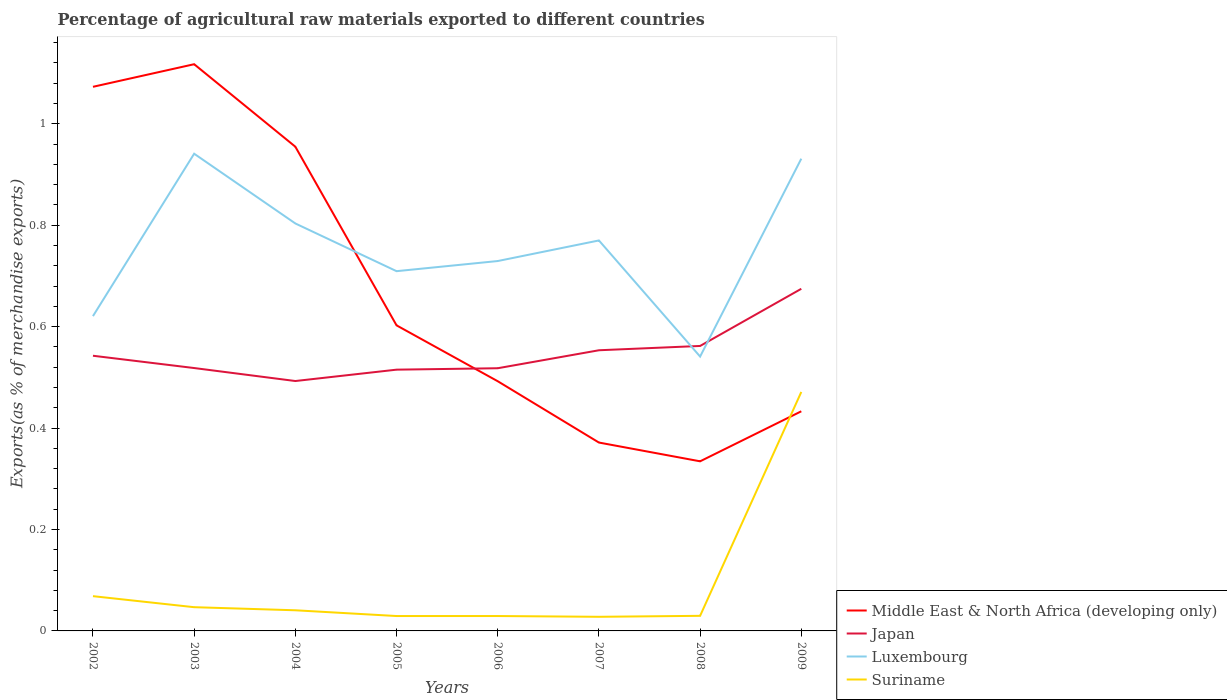How many different coloured lines are there?
Your response must be concise. 4. Is the number of lines equal to the number of legend labels?
Offer a terse response. Yes. Across all years, what is the maximum percentage of exports to different countries in Luxembourg?
Give a very brief answer. 0.54. In which year was the percentage of exports to different countries in Japan maximum?
Ensure brevity in your answer.  2004. What is the total percentage of exports to different countries in Middle East & North Africa (developing only) in the graph?
Your response must be concise. 0.17. What is the difference between the highest and the second highest percentage of exports to different countries in Luxembourg?
Keep it short and to the point. 0.4. Is the percentage of exports to different countries in Middle East & North Africa (developing only) strictly greater than the percentage of exports to different countries in Japan over the years?
Make the answer very short. No. How many lines are there?
Make the answer very short. 4. Does the graph contain any zero values?
Keep it short and to the point. No. What is the title of the graph?
Your answer should be compact. Percentage of agricultural raw materials exported to different countries. What is the label or title of the Y-axis?
Your answer should be compact. Exports(as % of merchandise exports). What is the Exports(as % of merchandise exports) of Middle East & North Africa (developing only) in 2002?
Offer a very short reply. 1.07. What is the Exports(as % of merchandise exports) of Japan in 2002?
Your answer should be compact. 0.54. What is the Exports(as % of merchandise exports) in Luxembourg in 2002?
Give a very brief answer. 0.62. What is the Exports(as % of merchandise exports) in Suriname in 2002?
Your answer should be compact. 0.07. What is the Exports(as % of merchandise exports) of Middle East & North Africa (developing only) in 2003?
Keep it short and to the point. 1.12. What is the Exports(as % of merchandise exports) of Japan in 2003?
Offer a very short reply. 0.52. What is the Exports(as % of merchandise exports) in Luxembourg in 2003?
Your response must be concise. 0.94. What is the Exports(as % of merchandise exports) of Suriname in 2003?
Your response must be concise. 0.05. What is the Exports(as % of merchandise exports) in Middle East & North Africa (developing only) in 2004?
Make the answer very short. 0.95. What is the Exports(as % of merchandise exports) of Japan in 2004?
Provide a short and direct response. 0.49. What is the Exports(as % of merchandise exports) of Luxembourg in 2004?
Your response must be concise. 0.8. What is the Exports(as % of merchandise exports) of Suriname in 2004?
Make the answer very short. 0.04. What is the Exports(as % of merchandise exports) of Middle East & North Africa (developing only) in 2005?
Offer a terse response. 0.6. What is the Exports(as % of merchandise exports) of Japan in 2005?
Ensure brevity in your answer.  0.52. What is the Exports(as % of merchandise exports) in Luxembourg in 2005?
Make the answer very short. 0.71. What is the Exports(as % of merchandise exports) of Suriname in 2005?
Offer a very short reply. 0.03. What is the Exports(as % of merchandise exports) of Middle East & North Africa (developing only) in 2006?
Ensure brevity in your answer.  0.49. What is the Exports(as % of merchandise exports) of Japan in 2006?
Your answer should be very brief. 0.52. What is the Exports(as % of merchandise exports) in Luxembourg in 2006?
Give a very brief answer. 0.73. What is the Exports(as % of merchandise exports) of Suriname in 2006?
Make the answer very short. 0.03. What is the Exports(as % of merchandise exports) of Middle East & North Africa (developing only) in 2007?
Offer a very short reply. 0.37. What is the Exports(as % of merchandise exports) of Japan in 2007?
Offer a very short reply. 0.55. What is the Exports(as % of merchandise exports) of Luxembourg in 2007?
Provide a succinct answer. 0.77. What is the Exports(as % of merchandise exports) in Suriname in 2007?
Keep it short and to the point. 0.03. What is the Exports(as % of merchandise exports) in Middle East & North Africa (developing only) in 2008?
Provide a succinct answer. 0.33. What is the Exports(as % of merchandise exports) of Japan in 2008?
Offer a very short reply. 0.56. What is the Exports(as % of merchandise exports) of Luxembourg in 2008?
Ensure brevity in your answer.  0.54. What is the Exports(as % of merchandise exports) of Suriname in 2008?
Your response must be concise. 0.03. What is the Exports(as % of merchandise exports) in Middle East & North Africa (developing only) in 2009?
Make the answer very short. 0.43. What is the Exports(as % of merchandise exports) in Japan in 2009?
Your answer should be compact. 0.67. What is the Exports(as % of merchandise exports) of Luxembourg in 2009?
Provide a short and direct response. 0.93. What is the Exports(as % of merchandise exports) in Suriname in 2009?
Offer a terse response. 0.47. Across all years, what is the maximum Exports(as % of merchandise exports) in Middle East & North Africa (developing only)?
Give a very brief answer. 1.12. Across all years, what is the maximum Exports(as % of merchandise exports) of Japan?
Your answer should be compact. 0.67. Across all years, what is the maximum Exports(as % of merchandise exports) in Luxembourg?
Your response must be concise. 0.94. Across all years, what is the maximum Exports(as % of merchandise exports) of Suriname?
Provide a succinct answer. 0.47. Across all years, what is the minimum Exports(as % of merchandise exports) of Middle East & North Africa (developing only)?
Your answer should be very brief. 0.33. Across all years, what is the minimum Exports(as % of merchandise exports) of Japan?
Make the answer very short. 0.49. Across all years, what is the minimum Exports(as % of merchandise exports) of Luxembourg?
Your answer should be compact. 0.54. Across all years, what is the minimum Exports(as % of merchandise exports) of Suriname?
Provide a short and direct response. 0.03. What is the total Exports(as % of merchandise exports) of Middle East & North Africa (developing only) in the graph?
Ensure brevity in your answer.  5.38. What is the total Exports(as % of merchandise exports) of Japan in the graph?
Your answer should be very brief. 4.38. What is the total Exports(as % of merchandise exports) in Luxembourg in the graph?
Your answer should be very brief. 6.05. What is the total Exports(as % of merchandise exports) of Suriname in the graph?
Your answer should be compact. 0.74. What is the difference between the Exports(as % of merchandise exports) in Middle East & North Africa (developing only) in 2002 and that in 2003?
Provide a short and direct response. -0.04. What is the difference between the Exports(as % of merchandise exports) of Japan in 2002 and that in 2003?
Give a very brief answer. 0.02. What is the difference between the Exports(as % of merchandise exports) in Luxembourg in 2002 and that in 2003?
Your answer should be compact. -0.32. What is the difference between the Exports(as % of merchandise exports) in Suriname in 2002 and that in 2003?
Your response must be concise. 0.02. What is the difference between the Exports(as % of merchandise exports) of Middle East & North Africa (developing only) in 2002 and that in 2004?
Offer a terse response. 0.12. What is the difference between the Exports(as % of merchandise exports) of Japan in 2002 and that in 2004?
Provide a short and direct response. 0.05. What is the difference between the Exports(as % of merchandise exports) of Luxembourg in 2002 and that in 2004?
Offer a terse response. -0.18. What is the difference between the Exports(as % of merchandise exports) of Suriname in 2002 and that in 2004?
Provide a succinct answer. 0.03. What is the difference between the Exports(as % of merchandise exports) in Middle East & North Africa (developing only) in 2002 and that in 2005?
Offer a terse response. 0.47. What is the difference between the Exports(as % of merchandise exports) of Japan in 2002 and that in 2005?
Keep it short and to the point. 0.03. What is the difference between the Exports(as % of merchandise exports) in Luxembourg in 2002 and that in 2005?
Offer a terse response. -0.09. What is the difference between the Exports(as % of merchandise exports) of Suriname in 2002 and that in 2005?
Keep it short and to the point. 0.04. What is the difference between the Exports(as % of merchandise exports) in Middle East & North Africa (developing only) in 2002 and that in 2006?
Provide a short and direct response. 0.58. What is the difference between the Exports(as % of merchandise exports) in Japan in 2002 and that in 2006?
Your answer should be very brief. 0.02. What is the difference between the Exports(as % of merchandise exports) of Luxembourg in 2002 and that in 2006?
Keep it short and to the point. -0.11. What is the difference between the Exports(as % of merchandise exports) in Suriname in 2002 and that in 2006?
Your response must be concise. 0.04. What is the difference between the Exports(as % of merchandise exports) of Middle East & North Africa (developing only) in 2002 and that in 2007?
Provide a short and direct response. 0.7. What is the difference between the Exports(as % of merchandise exports) in Japan in 2002 and that in 2007?
Your answer should be very brief. -0.01. What is the difference between the Exports(as % of merchandise exports) of Luxembourg in 2002 and that in 2007?
Your answer should be very brief. -0.15. What is the difference between the Exports(as % of merchandise exports) of Suriname in 2002 and that in 2007?
Make the answer very short. 0.04. What is the difference between the Exports(as % of merchandise exports) of Middle East & North Africa (developing only) in 2002 and that in 2008?
Give a very brief answer. 0.74. What is the difference between the Exports(as % of merchandise exports) of Japan in 2002 and that in 2008?
Offer a terse response. -0.02. What is the difference between the Exports(as % of merchandise exports) in Luxembourg in 2002 and that in 2008?
Make the answer very short. 0.08. What is the difference between the Exports(as % of merchandise exports) in Suriname in 2002 and that in 2008?
Your answer should be very brief. 0.04. What is the difference between the Exports(as % of merchandise exports) of Middle East & North Africa (developing only) in 2002 and that in 2009?
Give a very brief answer. 0.64. What is the difference between the Exports(as % of merchandise exports) in Japan in 2002 and that in 2009?
Keep it short and to the point. -0.13. What is the difference between the Exports(as % of merchandise exports) of Luxembourg in 2002 and that in 2009?
Your answer should be very brief. -0.31. What is the difference between the Exports(as % of merchandise exports) of Suriname in 2002 and that in 2009?
Offer a very short reply. -0.4. What is the difference between the Exports(as % of merchandise exports) in Middle East & North Africa (developing only) in 2003 and that in 2004?
Your response must be concise. 0.16. What is the difference between the Exports(as % of merchandise exports) in Japan in 2003 and that in 2004?
Your response must be concise. 0.03. What is the difference between the Exports(as % of merchandise exports) in Luxembourg in 2003 and that in 2004?
Your answer should be very brief. 0.14. What is the difference between the Exports(as % of merchandise exports) in Suriname in 2003 and that in 2004?
Offer a very short reply. 0.01. What is the difference between the Exports(as % of merchandise exports) in Middle East & North Africa (developing only) in 2003 and that in 2005?
Your answer should be very brief. 0.52. What is the difference between the Exports(as % of merchandise exports) in Japan in 2003 and that in 2005?
Your answer should be compact. 0. What is the difference between the Exports(as % of merchandise exports) in Luxembourg in 2003 and that in 2005?
Your response must be concise. 0.23. What is the difference between the Exports(as % of merchandise exports) in Suriname in 2003 and that in 2005?
Offer a terse response. 0.02. What is the difference between the Exports(as % of merchandise exports) in Middle East & North Africa (developing only) in 2003 and that in 2006?
Keep it short and to the point. 0.63. What is the difference between the Exports(as % of merchandise exports) of Japan in 2003 and that in 2006?
Give a very brief answer. 0. What is the difference between the Exports(as % of merchandise exports) in Luxembourg in 2003 and that in 2006?
Your response must be concise. 0.21. What is the difference between the Exports(as % of merchandise exports) of Suriname in 2003 and that in 2006?
Provide a short and direct response. 0.02. What is the difference between the Exports(as % of merchandise exports) of Middle East & North Africa (developing only) in 2003 and that in 2007?
Your answer should be very brief. 0.75. What is the difference between the Exports(as % of merchandise exports) in Japan in 2003 and that in 2007?
Keep it short and to the point. -0.04. What is the difference between the Exports(as % of merchandise exports) in Luxembourg in 2003 and that in 2007?
Offer a terse response. 0.17. What is the difference between the Exports(as % of merchandise exports) in Suriname in 2003 and that in 2007?
Offer a terse response. 0.02. What is the difference between the Exports(as % of merchandise exports) of Middle East & North Africa (developing only) in 2003 and that in 2008?
Make the answer very short. 0.78. What is the difference between the Exports(as % of merchandise exports) in Japan in 2003 and that in 2008?
Your response must be concise. -0.04. What is the difference between the Exports(as % of merchandise exports) of Luxembourg in 2003 and that in 2008?
Ensure brevity in your answer.  0.4. What is the difference between the Exports(as % of merchandise exports) of Suriname in 2003 and that in 2008?
Offer a terse response. 0.02. What is the difference between the Exports(as % of merchandise exports) of Middle East & North Africa (developing only) in 2003 and that in 2009?
Make the answer very short. 0.68. What is the difference between the Exports(as % of merchandise exports) in Japan in 2003 and that in 2009?
Ensure brevity in your answer.  -0.16. What is the difference between the Exports(as % of merchandise exports) in Luxembourg in 2003 and that in 2009?
Ensure brevity in your answer.  0.01. What is the difference between the Exports(as % of merchandise exports) of Suriname in 2003 and that in 2009?
Make the answer very short. -0.42. What is the difference between the Exports(as % of merchandise exports) in Middle East & North Africa (developing only) in 2004 and that in 2005?
Offer a terse response. 0.35. What is the difference between the Exports(as % of merchandise exports) of Japan in 2004 and that in 2005?
Your response must be concise. -0.02. What is the difference between the Exports(as % of merchandise exports) in Luxembourg in 2004 and that in 2005?
Your answer should be very brief. 0.09. What is the difference between the Exports(as % of merchandise exports) in Suriname in 2004 and that in 2005?
Keep it short and to the point. 0.01. What is the difference between the Exports(as % of merchandise exports) in Middle East & North Africa (developing only) in 2004 and that in 2006?
Offer a terse response. 0.46. What is the difference between the Exports(as % of merchandise exports) in Japan in 2004 and that in 2006?
Offer a terse response. -0.03. What is the difference between the Exports(as % of merchandise exports) in Luxembourg in 2004 and that in 2006?
Offer a terse response. 0.07. What is the difference between the Exports(as % of merchandise exports) in Suriname in 2004 and that in 2006?
Provide a short and direct response. 0.01. What is the difference between the Exports(as % of merchandise exports) of Middle East & North Africa (developing only) in 2004 and that in 2007?
Your answer should be compact. 0.58. What is the difference between the Exports(as % of merchandise exports) in Japan in 2004 and that in 2007?
Provide a succinct answer. -0.06. What is the difference between the Exports(as % of merchandise exports) in Luxembourg in 2004 and that in 2007?
Offer a very short reply. 0.03. What is the difference between the Exports(as % of merchandise exports) of Suriname in 2004 and that in 2007?
Offer a terse response. 0.01. What is the difference between the Exports(as % of merchandise exports) of Middle East & North Africa (developing only) in 2004 and that in 2008?
Make the answer very short. 0.62. What is the difference between the Exports(as % of merchandise exports) of Japan in 2004 and that in 2008?
Provide a short and direct response. -0.07. What is the difference between the Exports(as % of merchandise exports) in Luxembourg in 2004 and that in 2008?
Your response must be concise. 0.26. What is the difference between the Exports(as % of merchandise exports) in Suriname in 2004 and that in 2008?
Provide a succinct answer. 0.01. What is the difference between the Exports(as % of merchandise exports) in Middle East & North Africa (developing only) in 2004 and that in 2009?
Offer a very short reply. 0.52. What is the difference between the Exports(as % of merchandise exports) of Japan in 2004 and that in 2009?
Offer a terse response. -0.18. What is the difference between the Exports(as % of merchandise exports) of Luxembourg in 2004 and that in 2009?
Provide a short and direct response. -0.13. What is the difference between the Exports(as % of merchandise exports) of Suriname in 2004 and that in 2009?
Give a very brief answer. -0.43. What is the difference between the Exports(as % of merchandise exports) of Middle East & North Africa (developing only) in 2005 and that in 2006?
Ensure brevity in your answer.  0.11. What is the difference between the Exports(as % of merchandise exports) of Japan in 2005 and that in 2006?
Give a very brief answer. -0. What is the difference between the Exports(as % of merchandise exports) of Luxembourg in 2005 and that in 2006?
Make the answer very short. -0.02. What is the difference between the Exports(as % of merchandise exports) in Suriname in 2005 and that in 2006?
Keep it short and to the point. 0. What is the difference between the Exports(as % of merchandise exports) of Middle East & North Africa (developing only) in 2005 and that in 2007?
Your response must be concise. 0.23. What is the difference between the Exports(as % of merchandise exports) in Japan in 2005 and that in 2007?
Provide a succinct answer. -0.04. What is the difference between the Exports(as % of merchandise exports) of Luxembourg in 2005 and that in 2007?
Give a very brief answer. -0.06. What is the difference between the Exports(as % of merchandise exports) of Suriname in 2005 and that in 2007?
Provide a succinct answer. 0. What is the difference between the Exports(as % of merchandise exports) of Middle East & North Africa (developing only) in 2005 and that in 2008?
Make the answer very short. 0.27. What is the difference between the Exports(as % of merchandise exports) of Japan in 2005 and that in 2008?
Make the answer very short. -0.05. What is the difference between the Exports(as % of merchandise exports) of Luxembourg in 2005 and that in 2008?
Your response must be concise. 0.17. What is the difference between the Exports(as % of merchandise exports) of Suriname in 2005 and that in 2008?
Your response must be concise. -0. What is the difference between the Exports(as % of merchandise exports) in Middle East & North Africa (developing only) in 2005 and that in 2009?
Ensure brevity in your answer.  0.17. What is the difference between the Exports(as % of merchandise exports) in Japan in 2005 and that in 2009?
Make the answer very short. -0.16. What is the difference between the Exports(as % of merchandise exports) of Luxembourg in 2005 and that in 2009?
Offer a terse response. -0.22. What is the difference between the Exports(as % of merchandise exports) of Suriname in 2005 and that in 2009?
Keep it short and to the point. -0.44. What is the difference between the Exports(as % of merchandise exports) of Middle East & North Africa (developing only) in 2006 and that in 2007?
Make the answer very short. 0.12. What is the difference between the Exports(as % of merchandise exports) in Japan in 2006 and that in 2007?
Your response must be concise. -0.04. What is the difference between the Exports(as % of merchandise exports) of Luxembourg in 2006 and that in 2007?
Make the answer very short. -0.04. What is the difference between the Exports(as % of merchandise exports) of Suriname in 2006 and that in 2007?
Provide a succinct answer. 0. What is the difference between the Exports(as % of merchandise exports) of Middle East & North Africa (developing only) in 2006 and that in 2008?
Your answer should be very brief. 0.16. What is the difference between the Exports(as % of merchandise exports) in Japan in 2006 and that in 2008?
Your answer should be very brief. -0.04. What is the difference between the Exports(as % of merchandise exports) in Luxembourg in 2006 and that in 2008?
Provide a succinct answer. 0.19. What is the difference between the Exports(as % of merchandise exports) of Suriname in 2006 and that in 2008?
Provide a succinct answer. -0. What is the difference between the Exports(as % of merchandise exports) in Middle East & North Africa (developing only) in 2006 and that in 2009?
Give a very brief answer. 0.06. What is the difference between the Exports(as % of merchandise exports) of Japan in 2006 and that in 2009?
Your answer should be very brief. -0.16. What is the difference between the Exports(as % of merchandise exports) of Luxembourg in 2006 and that in 2009?
Offer a very short reply. -0.2. What is the difference between the Exports(as % of merchandise exports) of Suriname in 2006 and that in 2009?
Offer a terse response. -0.44. What is the difference between the Exports(as % of merchandise exports) in Middle East & North Africa (developing only) in 2007 and that in 2008?
Keep it short and to the point. 0.04. What is the difference between the Exports(as % of merchandise exports) in Japan in 2007 and that in 2008?
Make the answer very short. -0.01. What is the difference between the Exports(as % of merchandise exports) of Luxembourg in 2007 and that in 2008?
Offer a very short reply. 0.23. What is the difference between the Exports(as % of merchandise exports) of Suriname in 2007 and that in 2008?
Offer a terse response. -0. What is the difference between the Exports(as % of merchandise exports) of Middle East & North Africa (developing only) in 2007 and that in 2009?
Ensure brevity in your answer.  -0.06. What is the difference between the Exports(as % of merchandise exports) in Japan in 2007 and that in 2009?
Offer a terse response. -0.12. What is the difference between the Exports(as % of merchandise exports) in Luxembourg in 2007 and that in 2009?
Your answer should be compact. -0.16. What is the difference between the Exports(as % of merchandise exports) in Suriname in 2007 and that in 2009?
Provide a succinct answer. -0.44. What is the difference between the Exports(as % of merchandise exports) of Middle East & North Africa (developing only) in 2008 and that in 2009?
Provide a short and direct response. -0.1. What is the difference between the Exports(as % of merchandise exports) of Japan in 2008 and that in 2009?
Provide a short and direct response. -0.11. What is the difference between the Exports(as % of merchandise exports) of Luxembourg in 2008 and that in 2009?
Your response must be concise. -0.39. What is the difference between the Exports(as % of merchandise exports) in Suriname in 2008 and that in 2009?
Offer a terse response. -0.44. What is the difference between the Exports(as % of merchandise exports) of Middle East & North Africa (developing only) in 2002 and the Exports(as % of merchandise exports) of Japan in 2003?
Provide a short and direct response. 0.55. What is the difference between the Exports(as % of merchandise exports) of Middle East & North Africa (developing only) in 2002 and the Exports(as % of merchandise exports) of Luxembourg in 2003?
Your answer should be compact. 0.13. What is the difference between the Exports(as % of merchandise exports) of Middle East & North Africa (developing only) in 2002 and the Exports(as % of merchandise exports) of Suriname in 2003?
Your response must be concise. 1.03. What is the difference between the Exports(as % of merchandise exports) of Japan in 2002 and the Exports(as % of merchandise exports) of Luxembourg in 2003?
Give a very brief answer. -0.4. What is the difference between the Exports(as % of merchandise exports) of Japan in 2002 and the Exports(as % of merchandise exports) of Suriname in 2003?
Offer a terse response. 0.5. What is the difference between the Exports(as % of merchandise exports) of Luxembourg in 2002 and the Exports(as % of merchandise exports) of Suriname in 2003?
Give a very brief answer. 0.57. What is the difference between the Exports(as % of merchandise exports) in Middle East & North Africa (developing only) in 2002 and the Exports(as % of merchandise exports) in Japan in 2004?
Offer a very short reply. 0.58. What is the difference between the Exports(as % of merchandise exports) in Middle East & North Africa (developing only) in 2002 and the Exports(as % of merchandise exports) in Luxembourg in 2004?
Ensure brevity in your answer.  0.27. What is the difference between the Exports(as % of merchandise exports) in Middle East & North Africa (developing only) in 2002 and the Exports(as % of merchandise exports) in Suriname in 2004?
Keep it short and to the point. 1.03. What is the difference between the Exports(as % of merchandise exports) of Japan in 2002 and the Exports(as % of merchandise exports) of Luxembourg in 2004?
Keep it short and to the point. -0.26. What is the difference between the Exports(as % of merchandise exports) of Japan in 2002 and the Exports(as % of merchandise exports) of Suriname in 2004?
Ensure brevity in your answer.  0.5. What is the difference between the Exports(as % of merchandise exports) of Luxembourg in 2002 and the Exports(as % of merchandise exports) of Suriname in 2004?
Your response must be concise. 0.58. What is the difference between the Exports(as % of merchandise exports) in Middle East & North Africa (developing only) in 2002 and the Exports(as % of merchandise exports) in Japan in 2005?
Your answer should be compact. 0.56. What is the difference between the Exports(as % of merchandise exports) of Middle East & North Africa (developing only) in 2002 and the Exports(as % of merchandise exports) of Luxembourg in 2005?
Your answer should be compact. 0.36. What is the difference between the Exports(as % of merchandise exports) of Middle East & North Africa (developing only) in 2002 and the Exports(as % of merchandise exports) of Suriname in 2005?
Give a very brief answer. 1.04. What is the difference between the Exports(as % of merchandise exports) in Japan in 2002 and the Exports(as % of merchandise exports) in Luxembourg in 2005?
Offer a very short reply. -0.17. What is the difference between the Exports(as % of merchandise exports) of Japan in 2002 and the Exports(as % of merchandise exports) of Suriname in 2005?
Offer a very short reply. 0.51. What is the difference between the Exports(as % of merchandise exports) in Luxembourg in 2002 and the Exports(as % of merchandise exports) in Suriname in 2005?
Offer a very short reply. 0.59. What is the difference between the Exports(as % of merchandise exports) in Middle East & North Africa (developing only) in 2002 and the Exports(as % of merchandise exports) in Japan in 2006?
Offer a terse response. 0.56. What is the difference between the Exports(as % of merchandise exports) of Middle East & North Africa (developing only) in 2002 and the Exports(as % of merchandise exports) of Luxembourg in 2006?
Make the answer very short. 0.34. What is the difference between the Exports(as % of merchandise exports) of Middle East & North Africa (developing only) in 2002 and the Exports(as % of merchandise exports) of Suriname in 2006?
Your answer should be very brief. 1.04. What is the difference between the Exports(as % of merchandise exports) in Japan in 2002 and the Exports(as % of merchandise exports) in Luxembourg in 2006?
Provide a short and direct response. -0.19. What is the difference between the Exports(as % of merchandise exports) in Japan in 2002 and the Exports(as % of merchandise exports) in Suriname in 2006?
Offer a very short reply. 0.51. What is the difference between the Exports(as % of merchandise exports) of Luxembourg in 2002 and the Exports(as % of merchandise exports) of Suriname in 2006?
Your answer should be very brief. 0.59. What is the difference between the Exports(as % of merchandise exports) in Middle East & North Africa (developing only) in 2002 and the Exports(as % of merchandise exports) in Japan in 2007?
Make the answer very short. 0.52. What is the difference between the Exports(as % of merchandise exports) in Middle East & North Africa (developing only) in 2002 and the Exports(as % of merchandise exports) in Luxembourg in 2007?
Offer a terse response. 0.3. What is the difference between the Exports(as % of merchandise exports) in Middle East & North Africa (developing only) in 2002 and the Exports(as % of merchandise exports) in Suriname in 2007?
Offer a very short reply. 1.05. What is the difference between the Exports(as % of merchandise exports) of Japan in 2002 and the Exports(as % of merchandise exports) of Luxembourg in 2007?
Offer a terse response. -0.23. What is the difference between the Exports(as % of merchandise exports) in Japan in 2002 and the Exports(as % of merchandise exports) in Suriname in 2007?
Your response must be concise. 0.51. What is the difference between the Exports(as % of merchandise exports) of Luxembourg in 2002 and the Exports(as % of merchandise exports) of Suriname in 2007?
Give a very brief answer. 0.59. What is the difference between the Exports(as % of merchandise exports) of Middle East & North Africa (developing only) in 2002 and the Exports(as % of merchandise exports) of Japan in 2008?
Ensure brevity in your answer.  0.51. What is the difference between the Exports(as % of merchandise exports) in Middle East & North Africa (developing only) in 2002 and the Exports(as % of merchandise exports) in Luxembourg in 2008?
Provide a succinct answer. 0.53. What is the difference between the Exports(as % of merchandise exports) in Middle East & North Africa (developing only) in 2002 and the Exports(as % of merchandise exports) in Suriname in 2008?
Make the answer very short. 1.04. What is the difference between the Exports(as % of merchandise exports) of Japan in 2002 and the Exports(as % of merchandise exports) of Luxembourg in 2008?
Your response must be concise. 0. What is the difference between the Exports(as % of merchandise exports) of Japan in 2002 and the Exports(as % of merchandise exports) of Suriname in 2008?
Ensure brevity in your answer.  0.51. What is the difference between the Exports(as % of merchandise exports) in Luxembourg in 2002 and the Exports(as % of merchandise exports) in Suriname in 2008?
Provide a succinct answer. 0.59. What is the difference between the Exports(as % of merchandise exports) in Middle East & North Africa (developing only) in 2002 and the Exports(as % of merchandise exports) in Japan in 2009?
Offer a terse response. 0.4. What is the difference between the Exports(as % of merchandise exports) in Middle East & North Africa (developing only) in 2002 and the Exports(as % of merchandise exports) in Luxembourg in 2009?
Offer a terse response. 0.14. What is the difference between the Exports(as % of merchandise exports) in Middle East & North Africa (developing only) in 2002 and the Exports(as % of merchandise exports) in Suriname in 2009?
Make the answer very short. 0.6. What is the difference between the Exports(as % of merchandise exports) of Japan in 2002 and the Exports(as % of merchandise exports) of Luxembourg in 2009?
Ensure brevity in your answer.  -0.39. What is the difference between the Exports(as % of merchandise exports) in Japan in 2002 and the Exports(as % of merchandise exports) in Suriname in 2009?
Your response must be concise. 0.07. What is the difference between the Exports(as % of merchandise exports) in Luxembourg in 2002 and the Exports(as % of merchandise exports) in Suriname in 2009?
Offer a terse response. 0.15. What is the difference between the Exports(as % of merchandise exports) of Middle East & North Africa (developing only) in 2003 and the Exports(as % of merchandise exports) of Japan in 2004?
Provide a succinct answer. 0.62. What is the difference between the Exports(as % of merchandise exports) in Middle East & North Africa (developing only) in 2003 and the Exports(as % of merchandise exports) in Luxembourg in 2004?
Your answer should be compact. 0.31. What is the difference between the Exports(as % of merchandise exports) of Japan in 2003 and the Exports(as % of merchandise exports) of Luxembourg in 2004?
Your answer should be very brief. -0.29. What is the difference between the Exports(as % of merchandise exports) of Japan in 2003 and the Exports(as % of merchandise exports) of Suriname in 2004?
Give a very brief answer. 0.48. What is the difference between the Exports(as % of merchandise exports) of Luxembourg in 2003 and the Exports(as % of merchandise exports) of Suriname in 2004?
Make the answer very short. 0.9. What is the difference between the Exports(as % of merchandise exports) of Middle East & North Africa (developing only) in 2003 and the Exports(as % of merchandise exports) of Japan in 2005?
Offer a very short reply. 0.6. What is the difference between the Exports(as % of merchandise exports) in Middle East & North Africa (developing only) in 2003 and the Exports(as % of merchandise exports) in Luxembourg in 2005?
Offer a very short reply. 0.41. What is the difference between the Exports(as % of merchandise exports) in Middle East & North Africa (developing only) in 2003 and the Exports(as % of merchandise exports) in Suriname in 2005?
Provide a short and direct response. 1.09. What is the difference between the Exports(as % of merchandise exports) of Japan in 2003 and the Exports(as % of merchandise exports) of Luxembourg in 2005?
Ensure brevity in your answer.  -0.19. What is the difference between the Exports(as % of merchandise exports) of Japan in 2003 and the Exports(as % of merchandise exports) of Suriname in 2005?
Your response must be concise. 0.49. What is the difference between the Exports(as % of merchandise exports) of Luxembourg in 2003 and the Exports(as % of merchandise exports) of Suriname in 2005?
Offer a terse response. 0.91. What is the difference between the Exports(as % of merchandise exports) in Middle East & North Africa (developing only) in 2003 and the Exports(as % of merchandise exports) in Japan in 2006?
Keep it short and to the point. 0.6. What is the difference between the Exports(as % of merchandise exports) of Middle East & North Africa (developing only) in 2003 and the Exports(as % of merchandise exports) of Luxembourg in 2006?
Give a very brief answer. 0.39. What is the difference between the Exports(as % of merchandise exports) in Middle East & North Africa (developing only) in 2003 and the Exports(as % of merchandise exports) in Suriname in 2006?
Provide a short and direct response. 1.09. What is the difference between the Exports(as % of merchandise exports) of Japan in 2003 and the Exports(as % of merchandise exports) of Luxembourg in 2006?
Keep it short and to the point. -0.21. What is the difference between the Exports(as % of merchandise exports) of Japan in 2003 and the Exports(as % of merchandise exports) of Suriname in 2006?
Keep it short and to the point. 0.49. What is the difference between the Exports(as % of merchandise exports) of Luxembourg in 2003 and the Exports(as % of merchandise exports) of Suriname in 2006?
Offer a terse response. 0.91. What is the difference between the Exports(as % of merchandise exports) of Middle East & North Africa (developing only) in 2003 and the Exports(as % of merchandise exports) of Japan in 2007?
Provide a succinct answer. 0.56. What is the difference between the Exports(as % of merchandise exports) of Middle East & North Africa (developing only) in 2003 and the Exports(as % of merchandise exports) of Luxembourg in 2007?
Provide a succinct answer. 0.35. What is the difference between the Exports(as % of merchandise exports) in Middle East & North Africa (developing only) in 2003 and the Exports(as % of merchandise exports) in Suriname in 2007?
Keep it short and to the point. 1.09. What is the difference between the Exports(as % of merchandise exports) in Japan in 2003 and the Exports(as % of merchandise exports) in Luxembourg in 2007?
Your answer should be very brief. -0.25. What is the difference between the Exports(as % of merchandise exports) in Japan in 2003 and the Exports(as % of merchandise exports) in Suriname in 2007?
Ensure brevity in your answer.  0.49. What is the difference between the Exports(as % of merchandise exports) of Luxembourg in 2003 and the Exports(as % of merchandise exports) of Suriname in 2007?
Give a very brief answer. 0.91. What is the difference between the Exports(as % of merchandise exports) in Middle East & North Africa (developing only) in 2003 and the Exports(as % of merchandise exports) in Japan in 2008?
Your response must be concise. 0.56. What is the difference between the Exports(as % of merchandise exports) of Middle East & North Africa (developing only) in 2003 and the Exports(as % of merchandise exports) of Luxembourg in 2008?
Provide a succinct answer. 0.58. What is the difference between the Exports(as % of merchandise exports) of Middle East & North Africa (developing only) in 2003 and the Exports(as % of merchandise exports) of Suriname in 2008?
Keep it short and to the point. 1.09. What is the difference between the Exports(as % of merchandise exports) of Japan in 2003 and the Exports(as % of merchandise exports) of Luxembourg in 2008?
Provide a succinct answer. -0.02. What is the difference between the Exports(as % of merchandise exports) in Japan in 2003 and the Exports(as % of merchandise exports) in Suriname in 2008?
Keep it short and to the point. 0.49. What is the difference between the Exports(as % of merchandise exports) in Luxembourg in 2003 and the Exports(as % of merchandise exports) in Suriname in 2008?
Keep it short and to the point. 0.91. What is the difference between the Exports(as % of merchandise exports) in Middle East & North Africa (developing only) in 2003 and the Exports(as % of merchandise exports) in Japan in 2009?
Offer a very short reply. 0.44. What is the difference between the Exports(as % of merchandise exports) in Middle East & North Africa (developing only) in 2003 and the Exports(as % of merchandise exports) in Luxembourg in 2009?
Your answer should be compact. 0.19. What is the difference between the Exports(as % of merchandise exports) in Middle East & North Africa (developing only) in 2003 and the Exports(as % of merchandise exports) in Suriname in 2009?
Offer a very short reply. 0.65. What is the difference between the Exports(as % of merchandise exports) in Japan in 2003 and the Exports(as % of merchandise exports) in Luxembourg in 2009?
Offer a terse response. -0.41. What is the difference between the Exports(as % of merchandise exports) in Japan in 2003 and the Exports(as % of merchandise exports) in Suriname in 2009?
Offer a terse response. 0.05. What is the difference between the Exports(as % of merchandise exports) in Luxembourg in 2003 and the Exports(as % of merchandise exports) in Suriname in 2009?
Ensure brevity in your answer.  0.47. What is the difference between the Exports(as % of merchandise exports) of Middle East & North Africa (developing only) in 2004 and the Exports(as % of merchandise exports) of Japan in 2005?
Your response must be concise. 0.44. What is the difference between the Exports(as % of merchandise exports) of Middle East & North Africa (developing only) in 2004 and the Exports(as % of merchandise exports) of Luxembourg in 2005?
Offer a very short reply. 0.25. What is the difference between the Exports(as % of merchandise exports) of Middle East & North Africa (developing only) in 2004 and the Exports(as % of merchandise exports) of Suriname in 2005?
Your answer should be very brief. 0.93. What is the difference between the Exports(as % of merchandise exports) of Japan in 2004 and the Exports(as % of merchandise exports) of Luxembourg in 2005?
Make the answer very short. -0.22. What is the difference between the Exports(as % of merchandise exports) in Japan in 2004 and the Exports(as % of merchandise exports) in Suriname in 2005?
Ensure brevity in your answer.  0.46. What is the difference between the Exports(as % of merchandise exports) in Luxembourg in 2004 and the Exports(as % of merchandise exports) in Suriname in 2005?
Offer a terse response. 0.77. What is the difference between the Exports(as % of merchandise exports) of Middle East & North Africa (developing only) in 2004 and the Exports(as % of merchandise exports) of Japan in 2006?
Ensure brevity in your answer.  0.44. What is the difference between the Exports(as % of merchandise exports) in Middle East & North Africa (developing only) in 2004 and the Exports(as % of merchandise exports) in Luxembourg in 2006?
Your answer should be compact. 0.23. What is the difference between the Exports(as % of merchandise exports) in Middle East & North Africa (developing only) in 2004 and the Exports(as % of merchandise exports) in Suriname in 2006?
Provide a succinct answer. 0.93. What is the difference between the Exports(as % of merchandise exports) of Japan in 2004 and the Exports(as % of merchandise exports) of Luxembourg in 2006?
Make the answer very short. -0.24. What is the difference between the Exports(as % of merchandise exports) in Japan in 2004 and the Exports(as % of merchandise exports) in Suriname in 2006?
Provide a short and direct response. 0.46. What is the difference between the Exports(as % of merchandise exports) in Luxembourg in 2004 and the Exports(as % of merchandise exports) in Suriname in 2006?
Your response must be concise. 0.77. What is the difference between the Exports(as % of merchandise exports) in Middle East & North Africa (developing only) in 2004 and the Exports(as % of merchandise exports) in Japan in 2007?
Offer a terse response. 0.4. What is the difference between the Exports(as % of merchandise exports) of Middle East & North Africa (developing only) in 2004 and the Exports(as % of merchandise exports) of Luxembourg in 2007?
Provide a succinct answer. 0.18. What is the difference between the Exports(as % of merchandise exports) of Middle East & North Africa (developing only) in 2004 and the Exports(as % of merchandise exports) of Suriname in 2007?
Provide a short and direct response. 0.93. What is the difference between the Exports(as % of merchandise exports) of Japan in 2004 and the Exports(as % of merchandise exports) of Luxembourg in 2007?
Ensure brevity in your answer.  -0.28. What is the difference between the Exports(as % of merchandise exports) in Japan in 2004 and the Exports(as % of merchandise exports) in Suriname in 2007?
Offer a very short reply. 0.46. What is the difference between the Exports(as % of merchandise exports) of Luxembourg in 2004 and the Exports(as % of merchandise exports) of Suriname in 2007?
Your response must be concise. 0.78. What is the difference between the Exports(as % of merchandise exports) of Middle East & North Africa (developing only) in 2004 and the Exports(as % of merchandise exports) of Japan in 2008?
Offer a very short reply. 0.39. What is the difference between the Exports(as % of merchandise exports) in Middle East & North Africa (developing only) in 2004 and the Exports(as % of merchandise exports) in Luxembourg in 2008?
Your answer should be compact. 0.41. What is the difference between the Exports(as % of merchandise exports) of Middle East & North Africa (developing only) in 2004 and the Exports(as % of merchandise exports) of Suriname in 2008?
Provide a short and direct response. 0.93. What is the difference between the Exports(as % of merchandise exports) of Japan in 2004 and the Exports(as % of merchandise exports) of Luxembourg in 2008?
Your answer should be very brief. -0.05. What is the difference between the Exports(as % of merchandise exports) of Japan in 2004 and the Exports(as % of merchandise exports) of Suriname in 2008?
Make the answer very short. 0.46. What is the difference between the Exports(as % of merchandise exports) in Luxembourg in 2004 and the Exports(as % of merchandise exports) in Suriname in 2008?
Your response must be concise. 0.77. What is the difference between the Exports(as % of merchandise exports) of Middle East & North Africa (developing only) in 2004 and the Exports(as % of merchandise exports) of Japan in 2009?
Offer a very short reply. 0.28. What is the difference between the Exports(as % of merchandise exports) of Middle East & North Africa (developing only) in 2004 and the Exports(as % of merchandise exports) of Luxembourg in 2009?
Your answer should be very brief. 0.02. What is the difference between the Exports(as % of merchandise exports) of Middle East & North Africa (developing only) in 2004 and the Exports(as % of merchandise exports) of Suriname in 2009?
Provide a short and direct response. 0.48. What is the difference between the Exports(as % of merchandise exports) in Japan in 2004 and the Exports(as % of merchandise exports) in Luxembourg in 2009?
Your answer should be compact. -0.44. What is the difference between the Exports(as % of merchandise exports) in Japan in 2004 and the Exports(as % of merchandise exports) in Suriname in 2009?
Offer a very short reply. 0.02. What is the difference between the Exports(as % of merchandise exports) in Luxembourg in 2004 and the Exports(as % of merchandise exports) in Suriname in 2009?
Your response must be concise. 0.33. What is the difference between the Exports(as % of merchandise exports) in Middle East & North Africa (developing only) in 2005 and the Exports(as % of merchandise exports) in Japan in 2006?
Ensure brevity in your answer.  0.08. What is the difference between the Exports(as % of merchandise exports) in Middle East & North Africa (developing only) in 2005 and the Exports(as % of merchandise exports) in Luxembourg in 2006?
Provide a short and direct response. -0.13. What is the difference between the Exports(as % of merchandise exports) of Middle East & North Africa (developing only) in 2005 and the Exports(as % of merchandise exports) of Suriname in 2006?
Your response must be concise. 0.57. What is the difference between the Exports(as % of merchandise exports) in Japan in 2005 and the Exports(as % of merchandise exports) in Luxembourg in 2006?
Give a very brief answer. -0.21. What is the difference between the Exports(as % of merchandise exports) of Japan in 2005 and the Exports(as % of merchandise exports) of Suriname in 2006?
Provide a short and direct response. 0.49. What is the difference between the Exports(as % of merchandise exports) of Luxembourg in 2005 and the Exports(as % of merchandise exports) of Suriname in 2006?
Offer a very short reply. 0.68. What is the difference between the Exports(as % of merchandise exports) of Middle East & North Africa (developing only) in 2005 and the Exports(as % of merchandise exports) of Japan in 2007?
Offer a terse response. 0.05. What is the difference between the Exports(as % of merchandise exports) of Middle East & North Africa (developing only) in 2005 and the Exports(as % of merchandise exports) of Luxembourg in 2007?
Your answer should be very brief. -0.17. What is the difference between the Exports(as % of merchandise exports) in Middle East & North Africa (developing only) in 2005 and the Exports(as % of merchandise exports) in Suriname in 2007?
Your response must be concise. 0.57. What is the difference between the Exports(as % of merchandise exports) of Japan in 2005 and the Exports(as % of merchandise exports) of Luxembourg in 2007?
Your answer should be compact. -0.25. What is the difference between the Exports(as % of merchandise exports) of Japan in 2005 and the Exports(as % of merchandise exports) of Suriname in 2007?
Your response must be concise. 0.49. What is the difference between the Exports(as % of merchandise exports) of Luxembourg in 2005 and the Exports(as % of merchandise exports) of Suriname in 2007?
Offer a terse response. 0.68. What is the difference between the Exports(as % of merchandise exports) of Middle East & North Africa (developing only) in 2005 and the Exports(as % of merchandise exports) of Japan in 2008?
Offer a terse response. 0.04. What is the difference between the Exports(as % of merchandise exports) of Middle East & North Africa (developing only) in 2005 and the Exports(as % of merchandise exports) of Luxembourg in 2008?
Your answer should be very brief. 0.06. What is the difference between the Exports(as % of merchandise exports) in Middle East & North Africa (developing only) in 2005 and the Exports(as % of merchandise exports) in Suriname in 2008?
Ensure brevity in your answer.  0.57. What is the difference between the Exports(as % of merchandise exports) in Japan in 2005 and the Exports(as % of merchandise exports) in Luxembourg in 2008?
Your answer should be very brief. -0.03. What is the difference between the Exports(as % of merchandise exports) of Japan in 2005 and the Exports(as % of merchandise exports) of Suriname in 2008?
Provide a succinct answer. 0.49. What is the difference between the Exports(as % of merchandise exports) in Luxembourg in 2005 and the Exports(as % of merchandise exports) in Suriname in 2008?
Your answer should be very brief. 0.68. What is the difference between the Exports(as % of merchandise exports) of Middle East & North Africa (developing only) in 2005 and the Exports(as % of merchandise exports) of Japan in 2009?
Provide a succinct answer. -0.07. What is the difference between the Exports(as % of merchandise exports) in Middle East & North Africa (developing only) in 2005 and the Exports(as % of merchandise exports) in Luxembourg in 2009?
Offer a very short reply. -0.33. What is the difference between the Exports(as % of merchandise exports) of Middle East & North Africa (developing only) in 2005 and the Exports(as % of merchandise exports) of Suriname in 2009?
Your answer should be very brief. 0.13. What is the difference between the Exports(as % of merchandise exports) of Japan in 2005 and the Exports(as % of merchandise exports) of Luxembourg in 2009?
Provide a succinct answer. -0.42. What is the difference between the Exports(as % of merchandise exports) in Japan in 2005 and the Exports(as % of merchandise exports) in Suriname in 2009?
Ensure brevity in your answer.  0.04. What is the difference between the Exports(as % of merchandise exports) of Luxembourg in 2005 and the Exports(as % of merchandise exports) of Suriname in 2009?
Your answer should be compact. 0.24. What is the difference between the Exports(as % of merchandise exports) of Middle East & North Africa (developing only) in 2006 and the Exports(as % of merchandise exports) of Japan in 2007?
Your answer should be compact. -0.06. What is the difference between the Exports(as % of merchandise exports) of Middle East & North Africa (developing only) in 2006 and the Exports(as % of merchandise exports) of Luxembourg in 2007?
Give a very brief answer. -0.28. What is the difference between the Exports(as % of merchandise exports) of Middle East & North Africa (developing only) in 2006 and the Exports(as % of merchandise exports) of Suriname in 2007?
Offer a terse response. 0.46. What is the difference between the Exports(as % of merchandise exports) in Japan in 2006 and the Exports(as % of merchandise exports) in Luxembourg in 2007?
Ensure brevity in your answer.  -0.25. What is the difference between the Exports(as % of merchandise exports) in Japan in 2006 and the Exports(as % of merchandise exports) in Suriname in 2007?
Offer a very short reply. 0.49. What is the difference between the Exports(as % of merchandise exports) of Luxembourg in 2006 and the Exports(as % of merchandise exports) of Suriname in 2007?
Ensure brevity in your answer.  0.7. What is the difference between the Exports(as % of merchandise exports) of Middle East & North Africa (developing only) in 2006 and the Exports(as % of merchandise exports) of Japan in 2008?
Ensure brevity in your answer.  -0.07. What is the difference between the Exports(as % of merchandise exports) of Middle East & North Africa (developing only) in 2006 and the Exports(as % of merchandise exports) of Luxembourg in 2008?
Keep it short and to the point. -0.05. What is the difference between the Exports(as % of merchandise exports) in Middle East & North Africa (developing only) in 2006 and the Exports(as % of merchandise exports) in Suriname in 2008?
Offer a very short reply. 0.46. What is the difference between the Exports(as % of merchandise exports) of Japan in 2006 and the Exports(as % of merchandise exports) of Luxembourg in 2008?
Give a very brief answer. -0.02. What is the difference between the Exports(as % of merchandise exports) in Japan in 2006 and the Exports(as % of merchandise exports) in Suriname in 2008?
Your response must be concise. 0.49. What is the difference between the Exports(as % of merchandise exports) of Luxembourg in 2006 and the Exports(as % of merchandise exports) of Suriname in 2008?
Offer a terse response. 0.7. What is the difference between the Exports(as % of merchandise exports) in Middle East & North Africa (developing only) in 2006 and the Exports(as % of merchandise exports) in Japan in 2009?
Provide a succinct answer. -0.18. What is the difference between the Exports(as % of merchandise exports) in Middle East & North Africa (developing only) in 2006 and the Exports(as % of merchandise exports) in Luxembourg in 2009?
Offer a terse response. -0.44. What is the difference between the Exports(as % of merchandise exports) of Middle East & North Africa (developing only) in 2006 and the Exports(as % of merchandise exports) of Suriname in 2009?
Your answer should be very brief. 0.02. What is the difference between the Exports(as % of merchandise exports) of Japan in 2006 and the Exports(as % of merchandise exports) of Luxembourg in 2009?
Offer a terse response. -0.41. What is the difference between the Exports(as % of merchandise exports) in Japan in 2006 and the Exports(as % of merchandise exports) in Suriname in 2009?
Ensure brevity in your answer.  0.05. What is the difference between the Exports(as % of merchandise exports) of Luxembourg in 2006 and the Exports(as % of merchandise exports) of Suriname in 2009?
Offer a terse response. 0.26. What is the difference between the Exports(as % of merchandise exports) in Middle East & North Africa (developing only) in 2007 and the Exports(as % of merchandise exports) in Japan in 2008?
Provide a succinct answer. -0.19. What is the difference between the Exports(as % of merchandise exports) in Middle East & North Africa (developing only) in 2007 and the Exports(as % of merchandise exports) in Luxembourg in 2008?
Ensure brevity in your answer.  -0.17. What is the difference between the Exports(as % of merchandise exports) in Middle East & North Africa (developing only) in 2007 and the Exports(as % of merchandise exports) in Suriname in 2008?
Make the answer very short. 0.34. What is the difference between the Exports(as % of merchandise exports) of Japan in 2007 and the Exports(as % of merchandise exports) of Luxembourg in 2008?
Make the answer very short. 0.01. What is the difference between the Exports(as % of merchandise exports) of Japan in 2007 and the Exports(as % of merchandise exports) of Suriname in 2008?
Your answer should be very brief. 0.52. What is the difference between the Exports(as % of merchandise exports) of Luxembourg in 2007 and the Exports(as % of merchandise exports) of Suriname in 2008?
Provide a short and direct response. 0.74. What is the difference between the Exports(as % of merchandise exports) in Middle East & North Africa (developing only) in 2007 and the Exports(as % of merchandise exports) in Japan in 2009?
Give a very brief answer. -0.3. What is the difference between the Exports(as % of merchandise exports) of Middle East & North Africa (developing only) in 2007 and the Exports(as % of merchandise exports) of Luxembourg in 2009?
Offer a terse response. -0.56. What is the difference between the Exports(as % of merchandise exports) of Middle East & North Africa (developing only) in 2007 and the Exports(as % of merchandise exports) of Suriname in 2009?
Provide a short and direct response. -0.1. What is the difference between the Exports(as % of merchandise exports) in Japan in 2007 and the Exports(as % of merchandise exports) in Luxembourg in 2009?
Provide a short and direct response. -0.38. What is the difference between the Exports(as % of merchandise exports) in Japan in 2007 and the Exports(as % of merchandise exports) in Suriname in 2009?
Provide a succinct answer. 0.08. What is the difference between the Exports(as % of merchandise exports) in Luxembourg in 2007 and the Exports(as % of merchandise exports) in Suriname in 2009?
Give a very brief answer. 0.3. What is the difference between the Exports(as % of merchandise exports) in Middle East & North Africa (developing only) in 2008 and the Exports(as % of merchandise exports) in Japan in 2009?
Make the answer very short. -0.34. What is the difference between the Exports(as % of merchandise exports) in Middle East & North Africa (developing only) in 2008 and the Exports(as % of merchandise exports) in Luxembourg in 2009?
Offer a very short reply. -0.6. What is the difference between the Exports(as % of merchandise exports) in Middle East & North Africa (developing only) in 2008 and the Exports(as % of merchandise exports) in Suriname in 2009?
Offer a very short reply. -0.14. What is the difference between the Exports(as % of merchandise exports) in Japan in 2008 and the Exports(as % of merchandise exports) in Luxembourg in 2009?
Make the answer very short. -0.37. What is the difference between the Exports(as % of merchandise exports) in Japan in 2008 and the Exports(as % of merchandise exports) in Suriname in 2009?
Ensure brevity in your answer.  0.09. What is the difference between the Exports(as % of merchandise exports) in Luxembourg in 2008 and the Exports(as % of merchandise exports) in Suriname in 2009?
Ensure brevity in your answer.  0.07. What is the average Exports(as % of merchandise exports) in Middle East & North Africa (developing only) per year?
Make the answer very short. 0.67. What is the average Exports(as % of merchandise exports) of Japan per year?
Your response must be concise. 0.55. What is the average Exports(as % of merchandise exports) in Luxembourg per year?
Provide a short and direct response. 0.76. What is the average Exports(as % of merchandise exports) of Suriname per year?
Offer a terse response. 0.09. In the year 2002, what is the difference between the Exports(as % of merchandise exports) of Middle East & North Africa (developing only) and Exports(as % of merchandise exports) of Japan?
Provide a succinct answer. 0.53. In the year 2002, what is the difference between the Exports(as % of merchandise exports) in Middle East & North Africa (developing only) and Exports(as % of merchandise exports) in Luxembourg?
Provide a short and direct response. 0.45. In the year 2002, what is the difference between the Exports(as % of merchandise exports) in Japan and Exports(as % of merchandise exports) in Luxembourg?
Your answer should be very brief. -0.08. In the year 2002, what is the difference between the Exports(as % of merchandise exports) in Japan and Exports(as % of merchandise exports) in Suriname?
Your response must be concise. 0.47. In the year 2002, what is the difference between the Exports(as % of merchandise exports) in Luxembourg and Exports(as % of merchandise exports) in Suriname?
Keep it short and to the point. 0.55. In the year 2003, what is the difference between the Exports(as % of merchandise exports) in Middle East & North Africa (developing only) and Exports(as % of merchandise exports) in Japan?
Offer a very short reply. 0.6. In the year 2003, what is the difference between the Exports(as % of merchandise exports) of Middle East & North Africa (developing only) and Exports(as % of merchandise exports) of Luxembourg?
Provide a succinct answer. 0.18. In the year 2003, what is the difference between the Exports(as % of merchandise exports) of Middle East & North Africa (developing only) and Exports(as % of merchandise exports) of Suriname?
Make the answer very short. 1.07. In the year 2003, what is the difference between the Exports(as % of merchandise exports) in Japan and Exports(as % of merchandise exports) in Luxembourg?
Provide a short and direct response. -0.42. In the year 2003, what is the difference between the Exports(as % of merchandise exports) in Japan and Exports(as % of merchandise exports) in Suriname?
Ensure brevity in your answer.  0.47. In the year 2003, what is the difference between the Exports(as % of merchandise exports) in Luxembourg and Exports(as % of merchandise exports) in Suriname?
Offer a very short reply. 0.89. In the year 2004, what is the difference between the Exports(as % of merchandise exports) in Middle East & North Africa (developing only) and Exports(as % of merchandise exports) in Japan?
Offer a terse response. 0.46. In the year 2004, what is the difference between the Exports(as % of merchandise exports) of Middle East & North Africa (developing only) and Exports(as % of merchandise exports) of Luxembourg?
Keep it short and to the point. 0.15. In the year 2004, what is the difference between the Exports(as % of merchandise exports) in Middle East & North Africa (developing only) and Exports(as % of merchandise exports) in Suriname?
Make the answer very short. 0.91. In the year 2004, what is the difference between the Exports(as % of merchandise exports) of Japan and Exports(as % of merchandise exports) of Luxembourg?
Offer a very short reply. -0.31. In the year 2004, what is the difference between the Exports(as % of merchandise exports) of Japan and Exports(as % of merchandise exports) of Suriname?
Your response must be concise. 0.45. In the year 2004, what is the difference between the Exports(as % of merchandise exports) in Luxembourg and Exports(as % of merchandise exports) in Suriname?
Your answer should be compact. 0.76. In the year 2005, what is the difference between the Exports(as % of merchandise exports) of Middle East & North Africa (developing only) and Exports(as % of merchandise exports) of Japan?
Your answer should be compact. 0.09. In the year 2005, what is the difference between the Exports(as % of merchandise exports) in Middle East & North Africa (developing only) and Exports(as % of merchandise exports) in Luxembourg?
Make the answer very short. -0.11. In the year 2005, what is the difference between the Exports(as % of merchandise exports) of Middle East & North Africa (developing only) and Exports(as % of merchandise exports) of Suriname?
Give a very brief answer. 0.57. In the year 2005, what is the difference between the Exports(as % of merchandise exports) in Japan and Exports(as % of merchandise exports) in Luxembourg?
Give a very brief answer. -0.19. In the year 2005, what is the difference between the Exports(as % of merchandise exports) of Japan and Exports(as % of merchandise exports) of Suriname?
Your response must be concise. 0.49. In the year 2005, what is the difference between the Exports(as % of merchandise exports) in Luxembourg and Exports(as % of merchandise exports) in Suriname?
Make the answer very short. 0.68. In the year 2006, what is the difference between the Exports(as % of merchandise exports) in Middle East & North Africa (developing only) and Exports(as % of merchandise exports) in Japan?
Offer a terse response. -0.03. In the year 2006, what is the difference between the Exports(as % of merchandise exports) of Middle East & North Africa (developing only) and Exports(as % of merchandise exports) of Luxembourg?
Provide a succinct answer. -0.24. In the year 2006, what is the difference between the Exports(as % of merchandise exports) of Middle East & North Africa (developing only) and Exports(as % of merchandise exports) of Suriname?
Keep it short and to the point. 0.46. In the year 2006, what is the difference between the Exports(as % of merchandise exports) in Japan and Exports(as % of merchandise exports) in Luxembourg?
Make the answer very short. -0.21. In the year 2006, what is the difference between the Exports(as % of merchandise exports) of Japan and Exports(as % of merchandise exports) of Suriname?
Your response must be concise. 0.49. In the year 2006, what is the difference between the Exports(as % of merchandise exports) in Luxembourg and Exports(as % of merchandise exports) in Suriname?
Make the answer very short. 0.7. In the year 2007, what is the difference between the Exports(as % of merchandise exports) of Middle East & North Africa (developing only) and Exports(as % of merchandise exports) of Japan?
Your answer should be very brief. -0.18. In the year 2007, what is the difference between the Exports(as % of merchandise exports) in Middle East & North Africa (developing only) and Exports(as % of merchandise exports) in Luxembourg?
Offer a very short reply. -0.4. In the year 2007, what is the difference between the Exports(as % of merchandise exports) of Middle East & North Africa (developing only) and Exports(as % of merchandise exports) of Suriname?
Your response must be concise. 0.34. In the year 2007, what is the difference between the Exports(as % of merchandise exports) of Japan and Exports(as % of merchandise exports) of Luxembourg?
Make the answer very short. -0.22. In the year 2007, what is the difference between the Exports(as % of merchandise exports) of Japan and Exports(as % of merchandise exports) of Suriname?
Keep it short and to the point. 0.53. In the year 2007, what is the difference between the Exports(as % of merchandise exports) of Luxembourg and Exports(as % of merchandise exports) of Suriname?
Make the answer very short. 0.74. In the year 2008, what is the difference between the Exports(as % of merchandise exports) in Middle East & North Africa (developing only) and Exports(as % of merchandise exports) in Japan?
Make the answer very short. -0.23. In the year 2008, what is the difference between the Exports(as % of merchandise exports) of Middle East & North Africa (developing only) and Exports(as % of merchandise exports) of Luxembourg?
Offer a terse response. -0.21. In the year 2008, what is the difference between the Exports(as % of merchandise exports) in Middle East & North Africa (developing only) and Exports(as % of merchandise exports) in Suriname?
Ensure brevity in your answer.  0.3. In the year 2008, what is the difference between the Exports(as % of merchandise exports) in Japan and Exports(as % of merchandise exports) in Luxembourg?
Give a very brief answer. 0.02. In the year 2008, what is the difference between the Exports(as % of merchandise exports) of Japan and Exports(as % of merchandise exports) of Suriname?
Give a very brief answer. 0.53. In the year 2008, what is the difference between the Exports(as % of merchandise exports) of Luxembourg and Exports(as % of merchandise exports) of Suriname?
Give a very brief answer. 0.51. In the year 2009, what is the difference between the Exports(as % of merchandise exports) of Middle East & North Africa (developing only) and Exports(as % of merchandise exports) of Japan?
Provide a succinct answer. -0.24. In the year 2009, what is the difference between the Exports(as % of merchandise exports) of Middle East & North Africa (developing only) and Exports(as % of merchandise exports) of Luxembourg?
Offer a very short reply. -0.5. In the year 2009, what is the difference between the Exports(as % of merchandise exports) of Middle East & North Africa (developing only) and Exports(as % of merchandise exports) of Suriname?
Give a very brief answer. -0.04. In the year 2009, what is the difference between the Exports(as % of merchandise exports) in Japan and Exports(as % of merchandise exports) in Luxembourg?
Your response must be concise. -0.26. In the year 2009, what is the difference between the Exports(as % of merchandise exports) of Japan and Exports(as % of merchandise exports) of Suriname?
Your response must be concise. 0.2. In the year 2009, what is the difference between the Exports(as % of merchandise exports) of Luxembourg and Exports(as % of merchandise exports) of Suriname?
Provide a short and direct response. 0.46. What is the ratio of the Exports(as % of merchandise exports) of Middle East & North Africa (developing only) in 2002 to that in 2003?
Ensure brevity in your answer.  0.96. What is the ratio of the Exports(as % of merchandise exports) of Japan in 2002 to that in 2003?
Keep it short and to the point. 1.05. What is the ratio of the Exports(as % of merchandise exports) in Luxembourg in 2002 to that in 2003?
Keep it short and to the point. 0.66. What is the ratio of the Exports(as % of merchandise exports) of Suriname in 2002 to that in 2003?
Your answer should be compact. 1.46. What is the ratio of the Exports(as % of merchandise exports) in Middle East & North Africa (developing only) in 2002 to that in 2004?
Provide a succinct answer. 1.12. What is the ratio of the Exports(as % of merchandise exports) of Japan in 2002 to that in 2004?
Provide a succinct answer. 1.1. What is the ratio of the Exports(as % of merchandise exports) of Luxembourg in 2002 to that in 2004?
Offer a very short reply. 0.77. What is the ratio of the Exports(as % of merchandise exports) of Suriname in 2002 to that in 2004?
Ensure brevity in your answer.  1.68. What is the ratio of the Exports(as % of merchandise exports) of Middle East & North Africa (developing only) in 2002 to that in 2005?
Ensure brevity in your answer.  1.78. What is the ratio of the Exports(as % of merchandise exports) in Japan in 2002 to that in 2005?
Your answer should be compact. 1.05. What is the ratio of the Exports(as % of merchandise exports) in Suriname in 2002 to that in 2005?
Your answer should be very brief. 2.33. What is the ratio of the Exports(as % of merchandise exports) of Middle East & North Africa (developing only) in 2002 to that in 2006?
Ensure brevity in your answer.  2.18. What is the ratio of the Exports(as % of merchandise exports) in Japan in 2002 to that in 2006?
Your answer should be compact. 1.05. What is the ratio of the Exports(as % of merchandise exports) in Luxembourg in 2002 to that in 2006?
Provide a succinct answer. 0.85. What is the ratio of the Exports(as % of merchandise exports) in Suriname in 2002 to that in 2006?
Provide a short and direct response. 2.34. What is the ratio of the Exports(as % of merchandise exports) of Middle East & North Africa (developing only) in 2002 to that in 2007?
Your response must be concise. 2.89. What is the ratio of the Exports(as % of merchandise exports) of Japan in 2002 to that in 2007?
Offer a very short reply. 0.98. What is the ratio of the Exports(as % of merchandise exports) in Luxembourg in 2002 to that in 2007?
Make the answer very short. 0.81. What is the ratio of the Exports(as % of merchandise exports) in Suriname in 2002 to that in 2007?
Ensure brevity in your answer.  2.46. What is the ratio of the Exports(as % of merchandise exports) of Middle East & North Africa (developing only) in 2002 to that in 2008?
Keep it short and to the point. 3.21. What is the ratio of the Exports(as % of merchandise exports) of Japan in 2002 to that in 2008?
Give a very brief answer. 0.97. What is the ratio of the Exports(as % of merchandise exports) of Luxembourg in 2002 to that in 2008?
Your answer should be compact. 1.15. What is the ratio of the Exports(as % of merchandise exports) of Suriname in 2002 to that in 2008?
Provide a succinct answer. 2.3. What is the ratio of the Exports(as % of merchandise exports) of Middle East & North Africa (developing only) in 2002 to that in 2009?
Make the answer very short. 2.48. What is the ratio of the Exports(as % of merchandise exports) of Japan in 2002 to that in 2009?
Your response must be concise. 0.8. What is the ratio of the Exports(as % of merchandise exports) in Luxembourg in 2002 to that in 2009?
Your answer should be compact. 0.67. What is the ratio of the Exports(as % of merchandise exports) of Suriname in 2002 to that in 2009?
Make the answer very short. 0.15. What is the ratio of the Exports(as % of merchandise exports) in Middle East & North Africa (developing only) in 2003 to that in 2004?
Offer a terse response. 1.17. What is the ratio of the Exports(as % of merchandise exports) of Japan in 2003 to that in 2004?
Offer a terse response. 1.05. What is the ratio of the Exports(as % of merchandise exports) of Luxembourg in 2003 to that in 2004?
Offer a terse response. 1.17. What is the ratio of the Exports(as % of merchandise exports) of Suriname in 2003 to that in 2004?
Provide a succinct answer. 1.15. What is the ratio of the Exports(as % of merchandise exports) in Middle East & North Africa (developing only) in 2003 to that in 2005?
Your answer should be very brief. 1.85. What is the ratio of the Exports(as % of merchandise exports) in Luxembourg in 2003 to that in 2005?
Offer a terse response. 1.33. What is the ratio of the Exports(as % of merchandise exports) in Suriname in 2003 to that in 2005?
Make the answer very short. 1.59. What is the ratio of the Exports(as % of merchandise exports) of Middle East & North Africa (developing only) in 2003 to that in 2006?
Give a very brief answer. 2.27. What is the ratio of the Exports(as % of merchandise exports) in Japan in 2003 to that in 2006?
Offer a very short reply. 1. What is the ratio of the Exports(as % of merchandise exports) in Luxembourg in 2003 to that in 2006?
Keep it short and to the point. 1.29. What is the ratio of the Exports(as % of merchandise exports) of Suriname in 2003 to that in 2006?
Your answer should be compact. 1.59. What is the ratio of the Exports(as % of merchandise exports) of Middle East & North Africa (developing only) in 2003 to that in 2007?
Ensure brevity in your answer.  3.01. What is the ratio of the Exports(as % of merchandise exports) in Japan in 2003 to that in 2007?
Ensure brevity in your answer.  0.94. What is the ratio of the Exports(as % of merchandise exports) in Luxembourg in 2003 to that in 2007?
Offer a terse response. 1.22. What is the ratio of the Exports(as % of merchandise exports) in Suriname in 2003 to that in 2007?
Your answer should be very brief. 1.68. What is the ratio of the Exports(as % of merchandise exports) of Middle East & North Africa (developing only) in 2003 to that in 2008?
Provide a short and direct response. 3.34. What is the ratio of the Exports(as % of merchandise exports) in Japan in 2003 to that in 2008?
Your answer should be compact. 0.92. What is the ratio of the Exports(as % of merchandise exports) in Luxembourg in 2003 to that in 2008?
Offer a very short reply. 1.74. What is the ratio of the Exports(as % of merchandise exports) in Suriname in 2003 to that in 2008?
Provide a succinct answer. 1.57. What is the ratio of the Exports(as % of merchandise exports) of Middle East & North Africa (developing only) in 2003 to that in 2009?
Offer a terse response. 2.58. What is the ratio of the Exports(as % of merchandise exports) in Japan in 2003 to that in 2009?
Give a very brief answer. 0.77. What is the ratio of the Exports(as % of merchandise exports) in Luxembourg in 2003 to that in 2009?
Ensure brevity in your answer.  1.01. What is the ratio of the Exports(as % of merchandise exports) of Suriname in 2003 to that in 2009?
Your response must be concise. 0.1. What is the ratio of the Exports(as % of merchandise exports) of Middle East & North Africa (developing only) in 2004 to that in 2005?
Ensure brevity in your answer.  1.58. What is the ratio of the Exports(as % of merchandise exports) of Japan in 2004 to that in 2005?
Ensure brevity in your answer.  0.96. What is the ratio of the Exports(as % of merchandise exports) of Luxembourg in 2004 to that in 2005?
Your response must be concise. 1.13. What is the ratio of the Exports(as % of merchandise exports) in Suriname in 2004 to that in 2005?
Give a very brief answer. 1.39. What is the ratio of the Exports(as % of merchandise exports) of Middle East & North Africa (developing only) in 2004 to that in 2006?
Provide a short and direct response. 1.94. What is the ratio of the Exports(as % of merchandise exports) of Japan in 2004 to that in 2006?
Give a very brief answer. 0.95. What is the ratio of the Exports(as % of merchandise exports) of Luxembourg in 2004 to that in 2006?
Ensure brevity in your answer.  1.1. What is the ratio of the Exports(as % of merchandise exports) in Suriname in 2004 to that in 2006?
Your answer should be compact. 1.39. What is the ratio of the Exports(as % of merchandise exports) in Middle East & North Africa (developing only) in 2004 to that in 2007?
Offer a terse response. 2.57. What is the ratio of the Exports(as % of merchandise exports) of Japan in 2004 to that in 2007?
Your answer should be compact. 0.89. What is the ratio of the Exports(as % of merchandise exports) of Luxembourg in 2004 to that in 2007?
Give a very brief answer. 1.04. What is the ratio of the Exports(as % of merchandise exports) of Suriname in 2004 to that in 2007?
Provide a short and direct response. 1.46. What is the ratio of the Exports(as % of merchandise exports) of Middle East & North Africa (developing only) in 2004 to that in 2008?
Offer a terse response. 2.85. What is the ratio of the Exports(as % of merchandise exports) in Japan in 2004 to that in 2008?
Give a very brief answer. 0.88. What is the ratio of the Exports(as % of merchandise exports) of Luxembourg in 2004 to that in 2008?
Provide a short and direct response. 1.49. What is the ratio of the Exports(as % of merchandise exports) in Suriname in 2004 to that in 2008?
Your response must be concise. 1.37. What is the ratio of the Exports(as % of merchandise exports) of Middle East & North Africa (developing only) in 2004 to that in 2009?
Ensure brevity in your answer.  2.2. What is the ratio of the Exports(as % of merchandise exports) in Japan in 2004 to that in 2009?
Your response must be concise. 0.73. What is the ratio of the Exports(as % of merchandise exports) of Luxembourg in 2004 to that in 2009?
Provide a short and direct response. 0.86. What is the ratio of the Exports(as % of merchandise exports) of Suriname in 2004 to that in 2009?
Keep it short and to the point. 0.09. What is the ratio of the Exports(as % of merchandise exports) of Middle East & North Africa (developing only) in 2005 to that in 2006?
Offer a very short reply. 1.22. What is the ratio of the Exports(as % of merchandise exports) in Luxembourg in 2005 to that in 2006?
Give a very brief answer. 0.97. What is the ratio of the Exports(as % of merchandise exports) of Middle East & North Africa (developing only) in 2005 to that in 2007?
Keep it short and to the point. 1.62. What is the ratio of the Exports(as % of merchandise exports) in Japan in 2005 to that in 2007?
Ensure brevity in your answer.  0.93. What is the ratio of the Exports(as % of merchandise exports) of Luxembourg in 2005 to that in 2007?
Give a very brief answer. 0.92. What is the ratio of the Exports(as % of merchandise exports) in Suriname in 2005 to that in 2007?
Make the answer very short. 1.05. What is the ratio of the Exports(as % of merchandise exports) of Middle East & North Africa (developing only) in 2005 to that in 2008?
Your answer should be compact. 1.8. What is the ratio of the Exports(as % of merchandise exports) in Japan in 2005 to that in 2008?
Make the answer very short. 0.92. What is the ratio of the Exports(as % of merchandise exports) in Luxembourg in 2005 to that in 2008?
Give a very brief answer. 1.31. What is the ratio of the Exports(as % of merchandise exports) in Suriname in 2005 to that in 2008?
Your answer should be very brief. 0.99. What is the ratio of the Exports(as % of merchandise exports) of Middle East & North Africa (developing only) in 2005 to that in 2009?
Your answer should be very brief. 1.39. What is the ratio of the Exports(as % of merchandise exports) of Japan in 2005 to that in 2009?
Your answer should be compact. 0.76. What is the ratio of the Exports(as % of merchandise exports) of Luxembourg in 2005 to that in 2009?
Ensure brevity in your answer.  0.76. What is the ratio of the Exports(as % of merchandise exports) of Suriname in 2005 to that in 2009?
Offer a terse response. 0.06. What is the ratio of the Exports(as % of merchandise exports) in Middle East & North Africa (developing only) in 2006 to that in 2007?
Offer a very short reply. 1.33. What is the ratio of the Exports(as % of merchandise exports) of Japan in 2006 to that in 2007?
Give a very brief answer. 0.94. What is the ratio of the Exports(as % of merchandise exports) in Luxembourg in 2006 to that in 2007?
Your response must be concise. 0.95. What is the ratio of the Exports(as % of merchandise exports) in Suriname in 2006 to that in 2007?
Give a very brief answer. 1.05. What is the ratio of the Exports(as % of merchandise exports) in Middle East & North Africa (developing only) in 2006 to that in 2008?
Provide a succinct answer. 1.47. What is the ratio of the Exports(as % of merchandise exports) in Japan in 2006 to that in 2008?
Your answer should be very brief. 0.92. What is the ratio of the Exports(as % of merchandise exports) of Luxembourg in 2006 to that in 2008?
Your answer should be compact. 1.35. What is the ratio of the Exports(as % of merchandise exports) of Suriname in 2006 to that in 2008?
Ensure brevity in your answer.  0.99. What is the ratio of the Exports(as % of merchandise exports) in Middle East & North Africa (developing only) in 2006 to that in 2009?
Keep it short and to the point. 1.14. What is the ratio of the Exports(as % of merchandise exports) in Japan in 2006 to that in 2009?
Your response must be concise. 0.77. What is the ratio of the Exports(as % of merchandise exports) of Luxembourg in 2006 to that in 2009?
Give a very brief answer. 0.78. What is the ratio of the Exports(as % of merchandise exports) in Suriname in 2006 to that in 2009?
Your response must be concise. 0.06. What is the ratio of the Exports(as % of merchandise exports) in Middle East & North Africa (developing only) in 2007 to that in 2008?
Provide a short and direct response. 1.11. What is the ratio of the Exports(as % of merchandise exports) of Japan in 2007 to that in 2008?
Your answer should be compact. 0.98. What is the ratio of the Exports(as % of merchandise exports) in Luxembourg in 2007 to that in 2008?
Your response must be concise. 1.42. What is the ratio of the Exports(as % of merchandise exports) of Suriname in 2007 to that in 2008?
Ensure brevity in your answer.  0.94. What is the ratio of the Exports(as % of merchandise exports) in Middle East & North Africa (developing only) in 2007 to that in 2009?
Make the answer very short. 0.86. What is the ratio of the Exports(as % of merchandise exports) in Japan in 2007 to that in 2009?
Ensure brevity in your answer.  0.82. What is the ratio of the Exports(as % of merchandise exports) in Luxembourg in 2007 to that in 2009?
Offer a terse response. 0.83. What is the ratio of the Exports(as % of merchandise exports) of Suriname in 2007 to that in 2009?
Offer a very short reply. 0.06. What is the ratio of the Exports(as % of merchandise exports) in Middle East & North Africa (developing only) in 2008 to that in 2009?
Ensure brevity in your answer.  0.77. What is the ratio of the Exports(as % of merchandise exports) of Japan in 2008 to that in 2009?
Your answer should be compact. 0.83. What is the ratio of the Exports(as % of merchandise exports) of Luxembourg in 2008 to that in 2009?
Keep it short and to the point. 0.58. What is the ratio of the Exports(as % of merchandise exports) of Suriname in 2008 to that in 2009?
Keep it short and to the point. 0.06. What is the difference between the highest and the second highest Exports(as % of merchandise exports) of Middle East & North Africa (developing only)?
Provide a succinct answer. 0.04. What is the difference between the highest and the second highest Exports(as % of merchandise exports) of Japan?
Keep it short and to the point. 0.11. What is the difference between the highest and the second highest Exports(as % of merchandise exports) in Luxembourg?
Make the answer very short. 0.01. What is the difference between the highest and the second highest Exports(as % of merchandise exports) of Suriname?
Provide a succinct answer. 0.4. What is the difference between the highest and the lowest Exports(as % of merchandise exports) in Middle East & North Africa (developing only)?
Provide a short and direct response. 0.78. What is the difference between the highest and the lowest Exports(as % of merchandise exports) in Japan?
Your response must be concise. 0.18. What is the difference between the highest and the lowest Exports(as % of merchandise exports) of Luxembourg?
Provide a succinct answer. 0.4. What is the difference between the highest and the lowest Exports(as % of merchandise exports) in Suriname?
Provide a succinct answer. 0.44. 